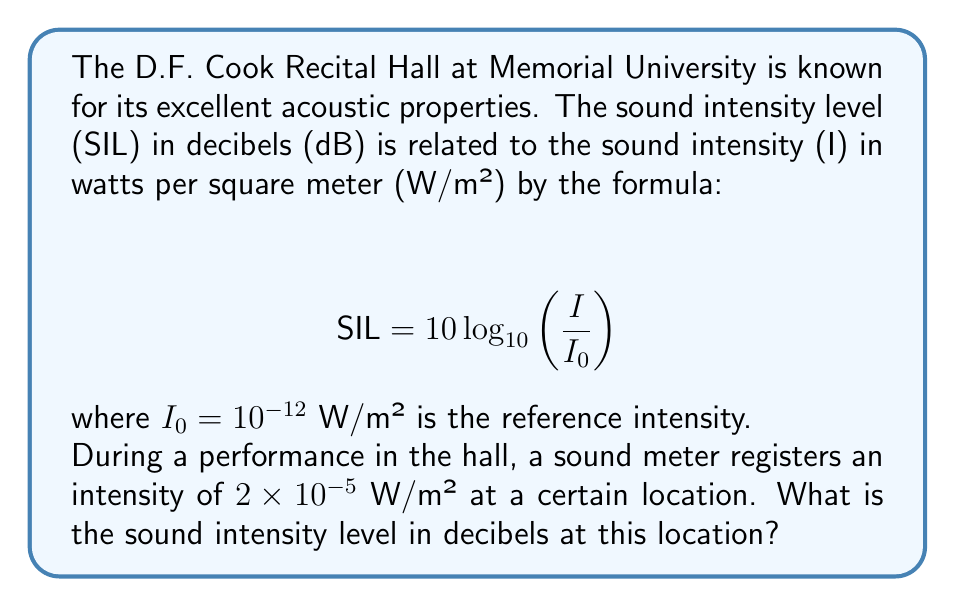Show me your answer to this math problem. To solve this problem, we'll use the given logarithmic function and follow these steps:

1) We're given that $I = 2 \times 10^{-5}$ W/m² and $I_0 = 10^{-12}$ W/m².

2) Let's substitute these values into the formula:

   $$ SIL = 10 \log_{10}\left(\frac{2 \times 10^{-5}}{10^{-12}}\right) $$

3) Simplify the fraction inside the logarithm:

   $$ SIL = 10 \log_{10}(2 \times 10^7) $$

4) Use the logarithm property $\log_a(x \times y) = \log_a(x) + \log_a(y)$:

   $$ SIL = 10 [\log_{10}(2) + \log_{10}(10^7)] $$

5) Simplify $\log_{10}(10^7) = 7$:

   $$ SIL = 10 [\log_{10}(2) + 7] $$

6) Calculate $\log_{10}(2) \approx 0.301$:

   $$ SIL = 10 [0.301 + 7] = 10(7.301) = 73.01 $$

Therefore, the sound intensity level is approximately 73.01 dB.
Answer: 73.01 dB 